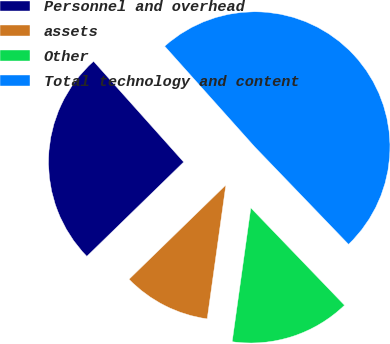Convert chart to OTSL. <chart><loc_0><loc_0><loc_500><loc_500><pie_chart><fcel>Personnel and overhead<fcel>assets<fcel>Other<fcel>Total technology and content<nl><fcel>25.67%<fcel>10.51%<fcel>14.4%<fcel>49.42%<nl></chart> 